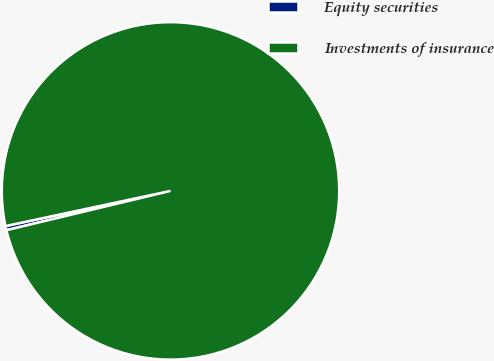Convert chart to OTSL. <chart><loc_0><loc_0><loc_500><loc_500><pie_chart><fcel>Equity securities<fcel>Investments of insurance<nl><fcel>0.4%<fcel>99.6%<nl></chart> 